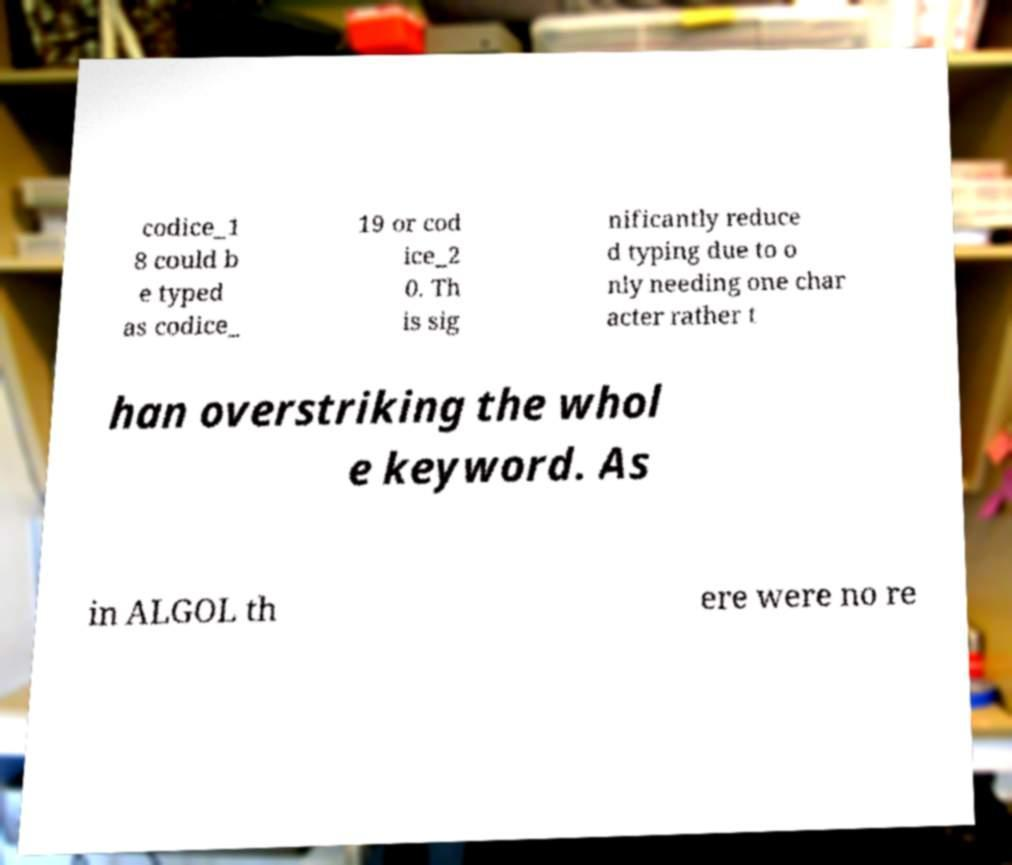Can you accurately transcribe the text from the provided image for me? codice_1 8 could b e typed as codice_ 19 or cod ice_2 0. Th is sig nificantly reduce d typing due to o nly needing one char acter rather t han overstriking the whol e keyword. As in ALGOL th ere were no re 